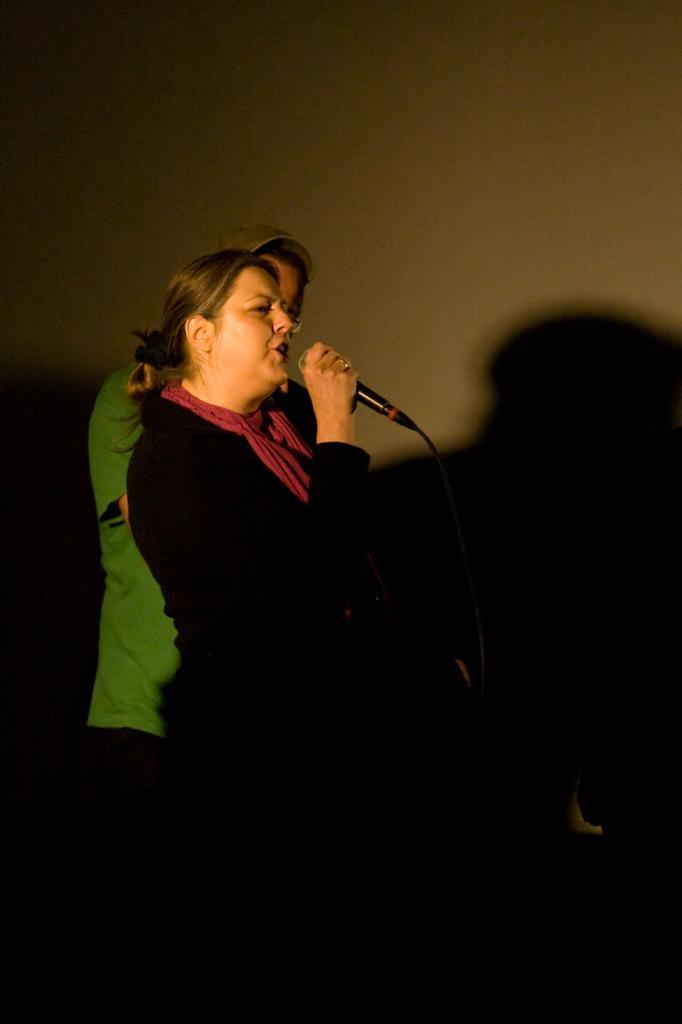Please provide a concise description of this image. The woman in front of the picture wearing a black T-shirt and pink scarf is holding a microphone in her hand. She is singing the song on the microphone. Beside her, we see a man in green T-shirt is standing. In the background, we see a wall. At the bottom of the picture, it is black in color. This picture is clicked in the dark. 